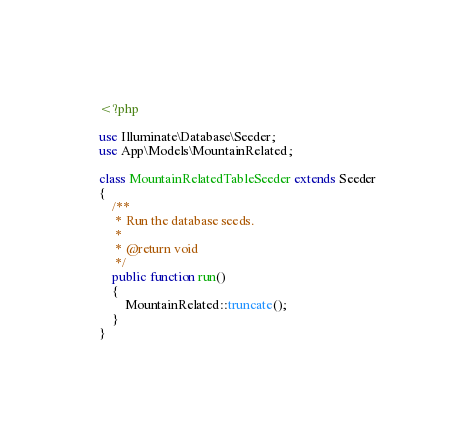Convert code to text. <code><loc_0><loc_0><loc_500><loc_500><_PHP_><?php

use Illuminate\Database\Seeder;
use App\Models\MountainRelated;

class MountainRelatedTableSeeder extends Seeder
{
    /**
     * Run the database seeds.
     *
     * @return void
     */
    public function run()
    {
        MountainRelated::truncate();
    }
}
</code> 